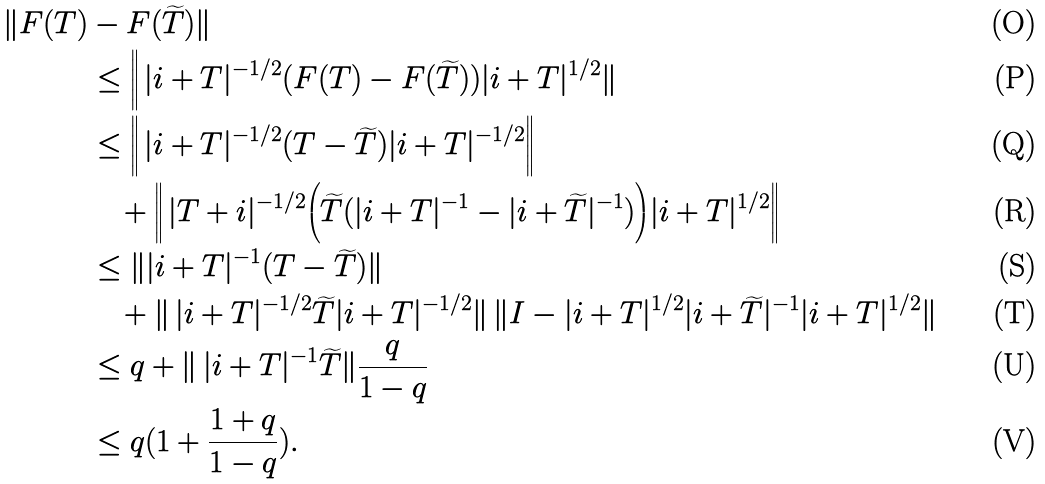Convert formula to latex. <formula><loc_0><loc_0><loc_500><loc_500>\| F ( T ) & - F ( \widetilde { T } ) \| \\ & \leq \Big \| \, | i + T | ^ { - 1 / 2 } ( F ( T ) - F ( \widetilde { T } ) ) | i + T | ^ { 1 / 2 } \| \\ & \leq \Big \| \, | i + T | ^ { - 1 / 2 } ( T - \widetilde { T } ) | i + T | ^ { - 1 / 2 } \Big \| \\ & \quad + \Big \| \, | T + i | ^ { - 1 / 2 } \Big ( \widetilde { T } ( | i + T | ^ { - 1 } - | i + \widetilde { T } | ^ { - 1 } ) \Big ) | i + T | ^ { 1 / 2 } \Big \| \\ & \leq \| | i + T | ^ { - 1 } ( T - \widetilde { T } ) \| \\ & \quad + \| \, | i + T | ^ { - 1 / 2 } \widetilde { T } | i + T | ^ { - 1 / 2 } \| \, \| I - | i + T | ^ { 1 / 2 } | i + \widetilde { T } | ^ { - 1 } | i + T | ^ { 1 / 2 } \| \\ & \leq q + \| \, | i + T | ^ { - 1 } \widetilde { T } \| \frac { q } { 1 - q } \\ & \leq q ( 1 + \frac { 1 + q } { 1 - q } ) .</formula> 